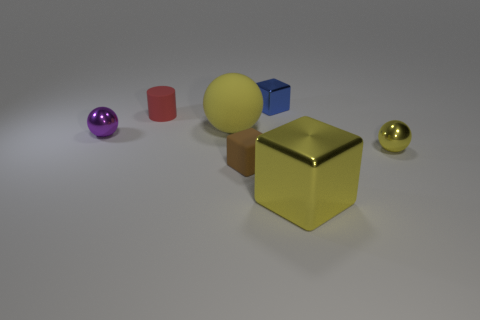Subtract all tiny purple balls. How many balls are left? 2 Add 3 big brown shiny cylinders. How many objects exist? 10 Subtract 1 blocks. How many blocks are left? 2 Subtract all blue blocks. How many blocks are left? 2 Subtract all red cylinders. How many yellow balls are left? 2 Subtract 0 gray blocks. How many objects are left? 7 Subtract all blocks. How many objects are left? 4 Subtract all brown cubes. Subtract all green cylinders. How many cubes are left? 2 Subtract all blocks. Subtract all big yellow rubber cubes. How many objects are left? 4 Add 3 large yellow matte spheres. How many large yellow matte spheres are left? 4 